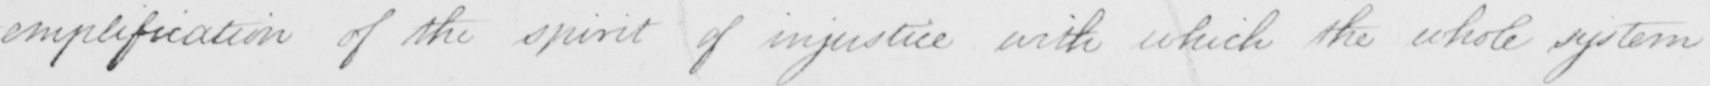Can you read and transcribe this handwriting? -emplification of the spirit of injustice with which the whole system 